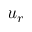Convert formula to latex. <formula><loc_0><loc_0><loc_500><loc_500>u _ { r }</formula> 